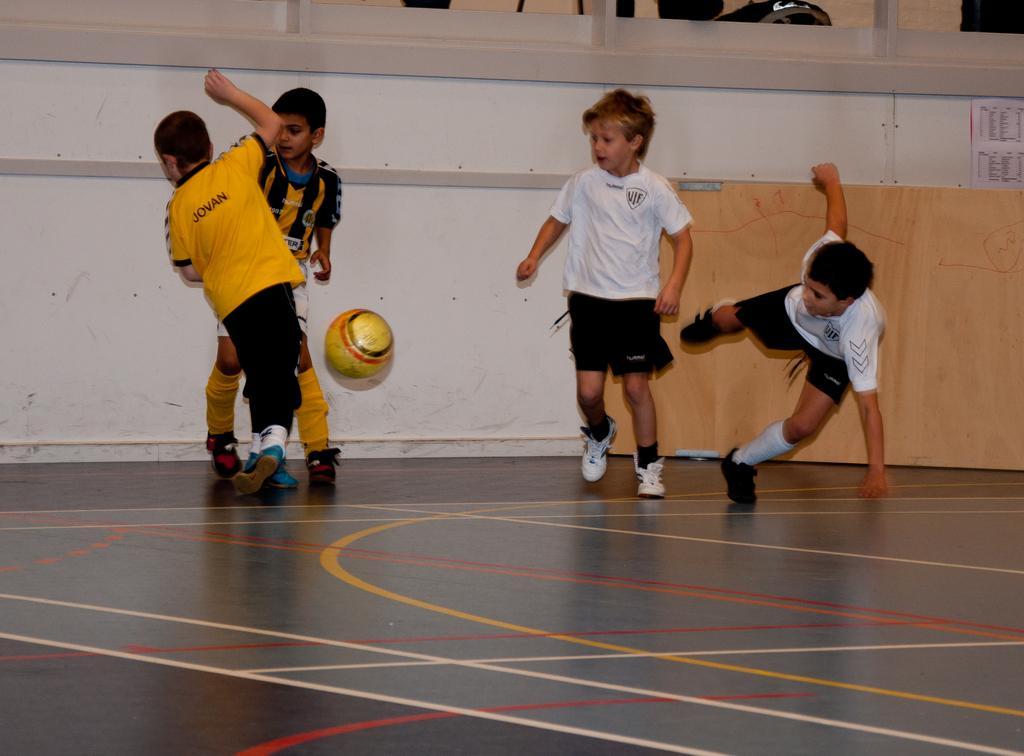In one or two sentences, can you explain what this image depicts? In this image children are playing football. 